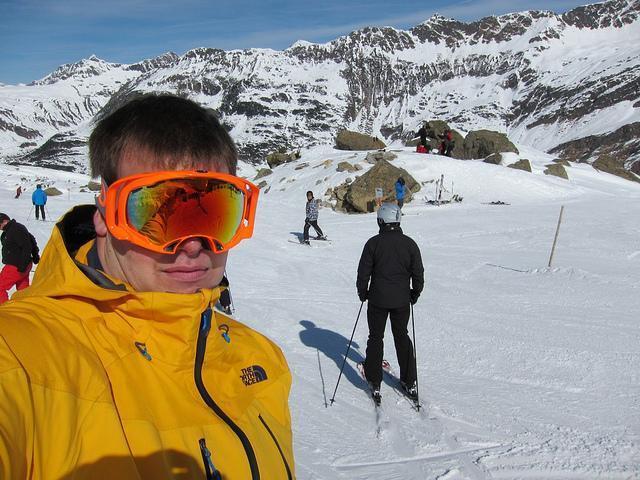How many people are visible?
Give a very brief answer. 3. How many umbrellas are closed?
Give a very brief answer. 0. 